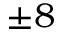<formula> <loc_0><loc_0><loc_500><loc_500>\pm 8</formula> 